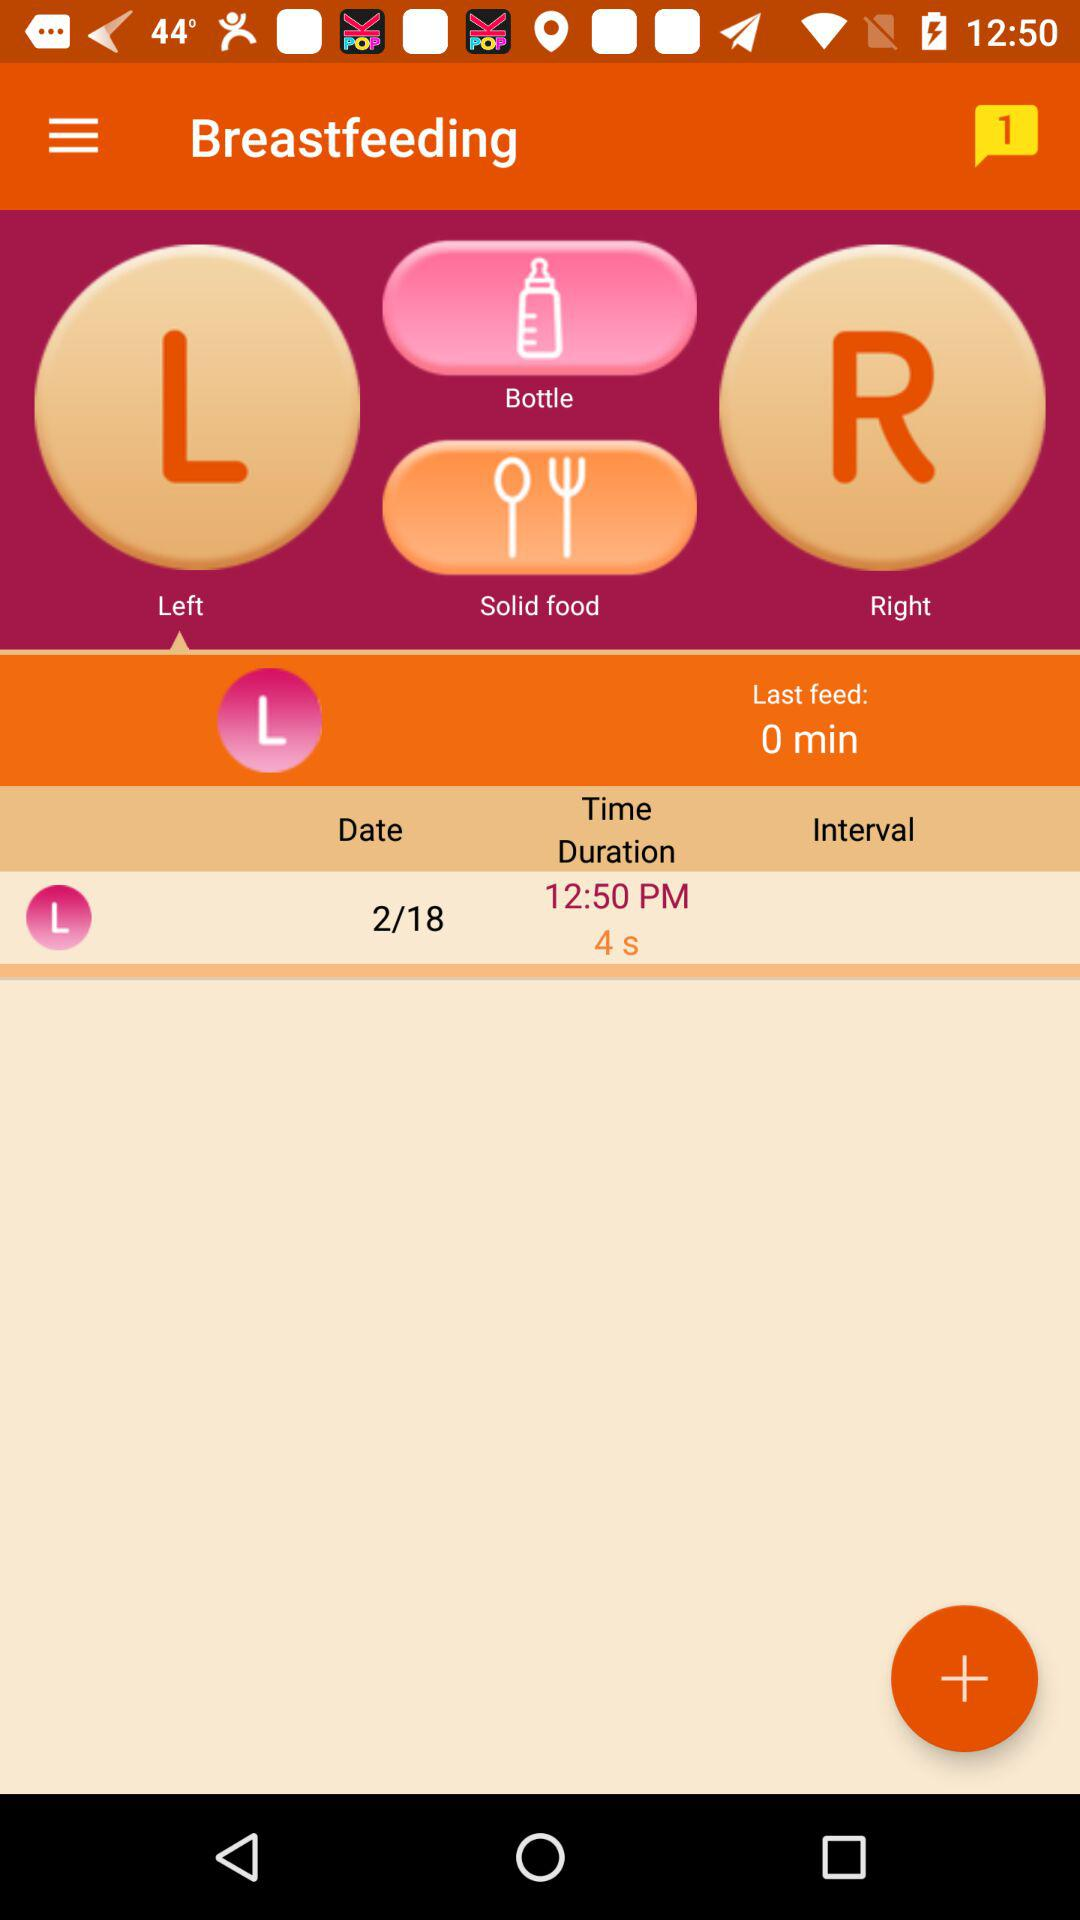What is the time duration of left breastfeeding? The time duration is 4 seconds. 